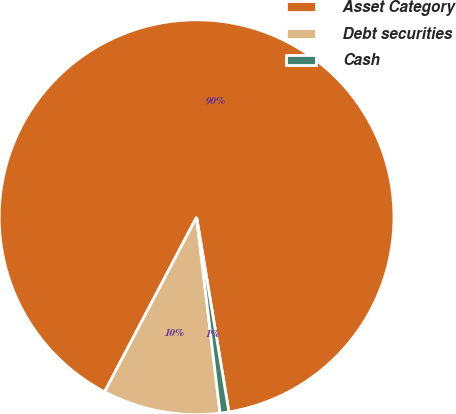Convert chart to OTSL. <chart><loc_0><loc_0><loc_500><loc_500><pie_chart><fcel>Asset Category<fcel>Debt securities<fcel>Cash<nl><fcel>89.67%<fcel>9.61%<fcel>0.72%<nl></chart> 